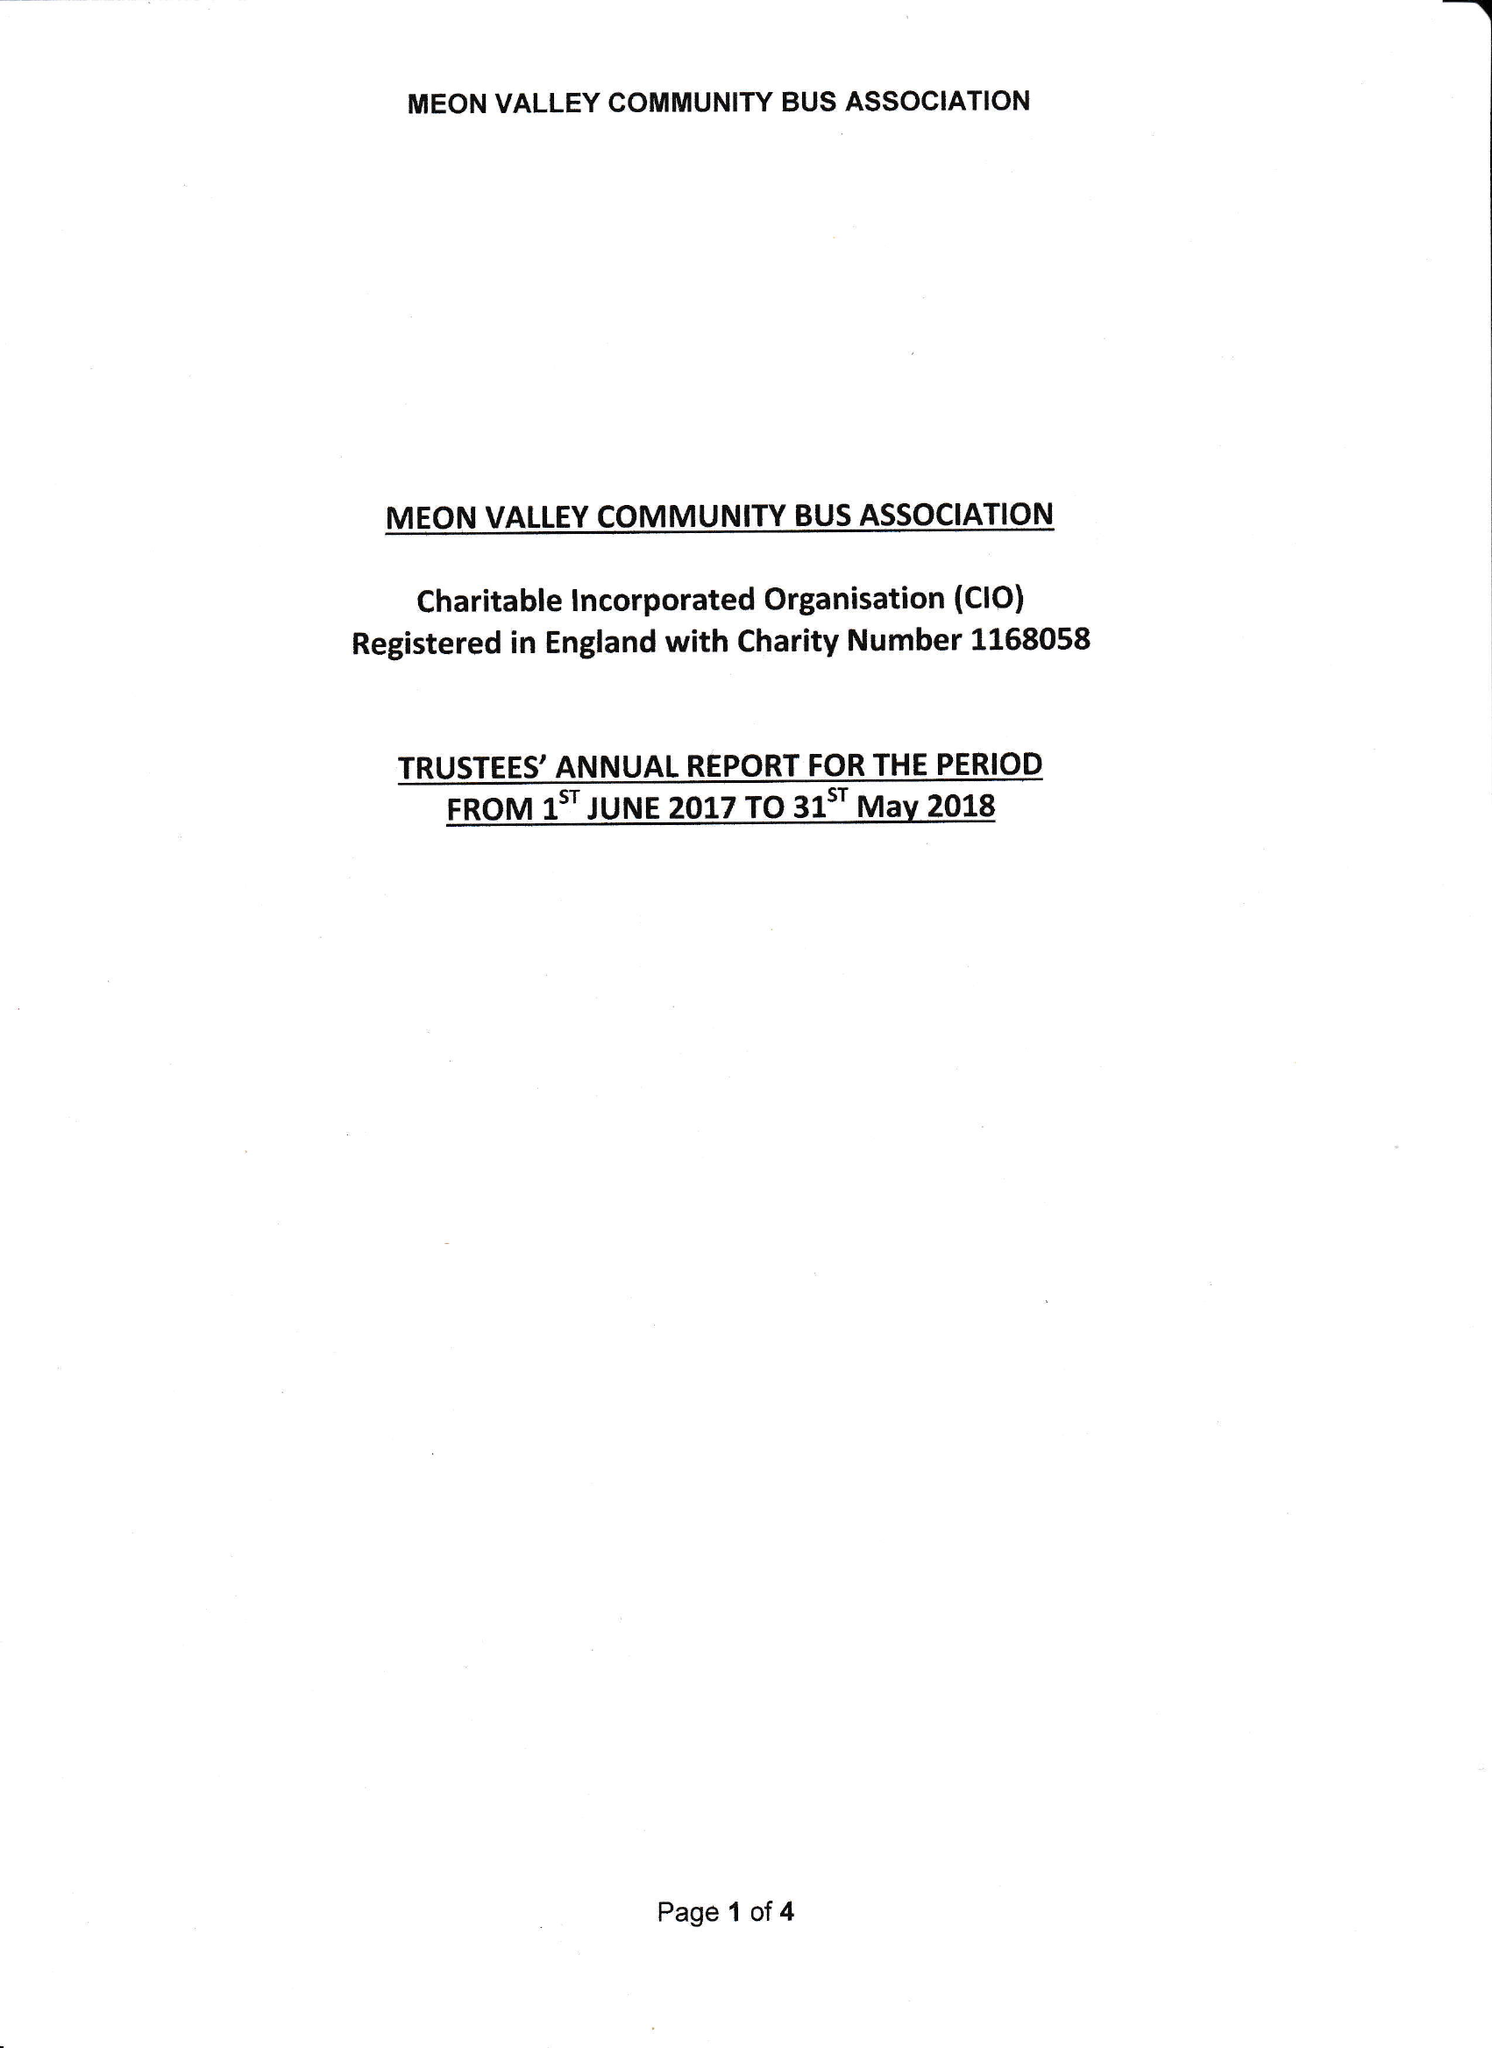What is the value for the address__street_line?
Answer the question using a single word or phrase. STATION ROAD 